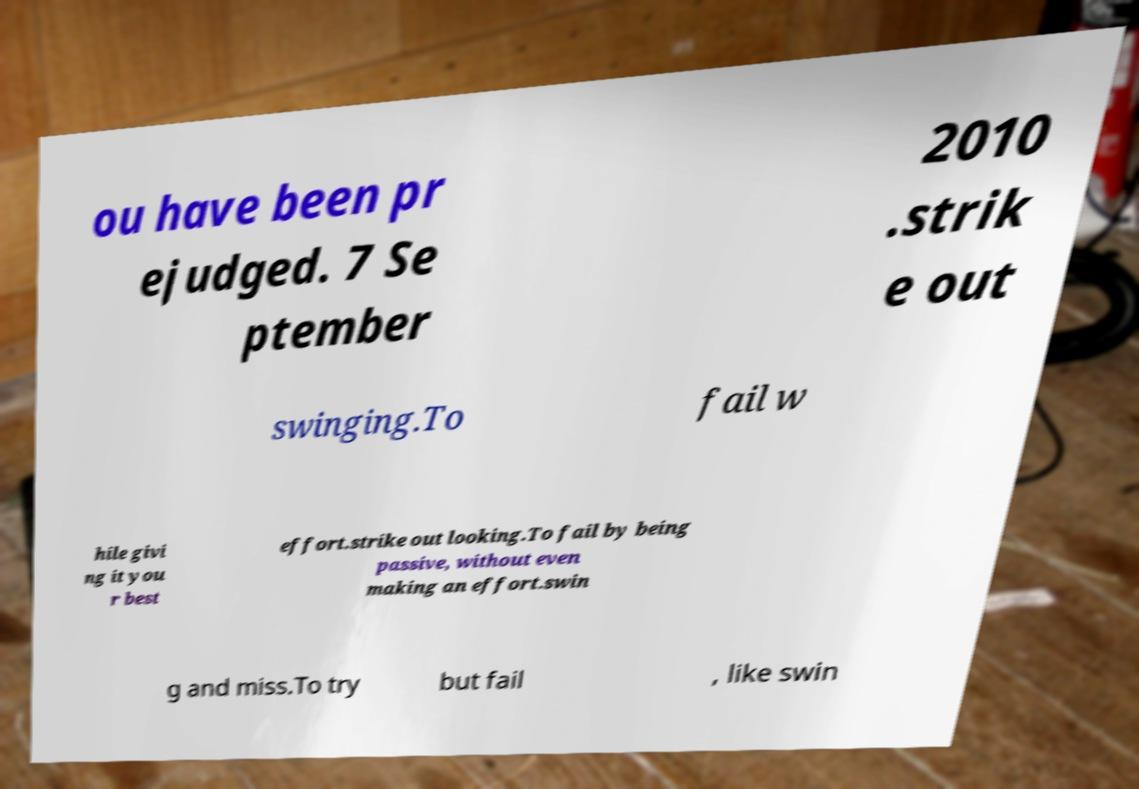What messages or text are displayed in this image? I need them in a readable, typed format. ou have been pr ejudged. 7 Se ptember 2010 .strik e out swinging.To fail w hile givi ng it you r best effort.strike out looking.To fail by being passive, without even making an effort.swin g and miss.To try but fail , like swin 